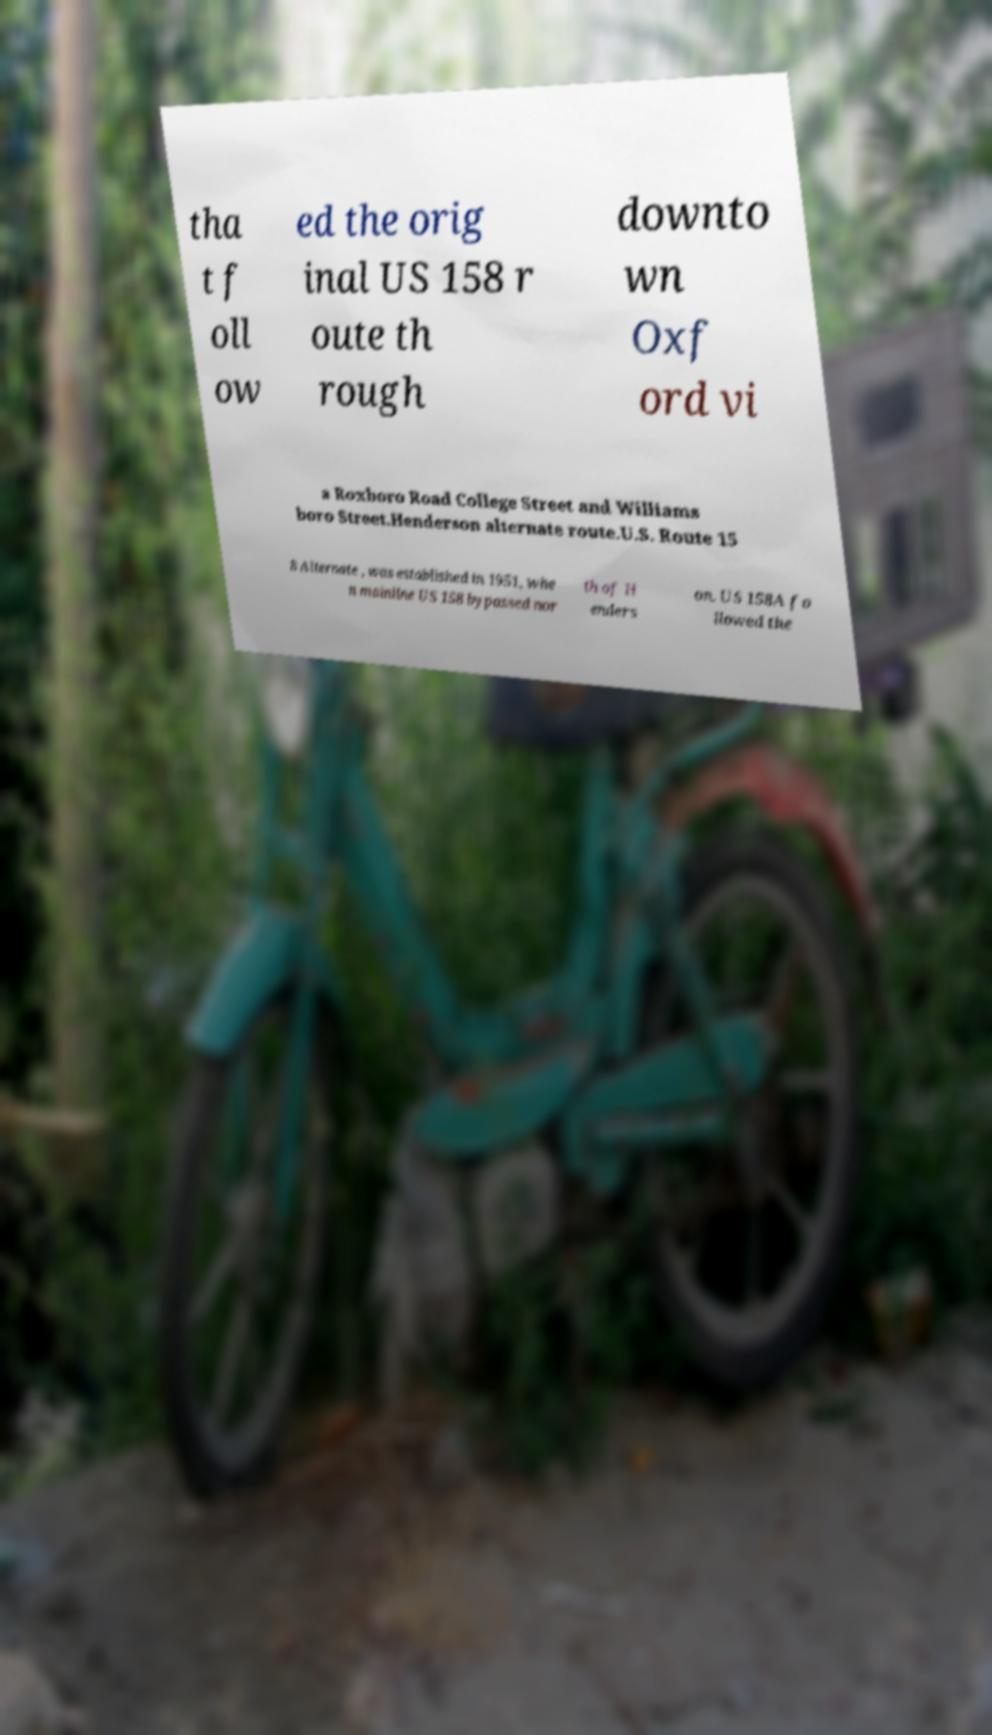Please read and relay the text visible in this image. What does it say? tha t f oll ow ed the orig inal US 158 r oute th rough downto wn Oxf ord vi a Roxboro Road College Street and Williams boro Street.Henderson alternate route.U.S. Route 15 8 Alternate , was established in 1951, whe n mainline US 158 bypassed nor th of H enders on. US 158A fo llowed the 